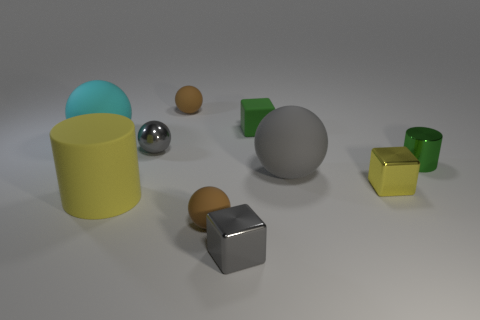Are the large gray object and the green cylinder made of the same material?
Keep it short and to the point. No. There is a green thing that is the same material as the yellow cylinder; what is its size?
Offer a very short reply. Small. What is the shape of the tiny rubber thing that is both behind the green cylinder and to the left of the tiny gray cube?
Ensure brevity in your answer.  Sphere. Is the number of green cylinders in front of the gray rubber sphere greater than the number of small gray things in front of the green metal object?
Give a very brief answer. No. What size is the rubber thing that is in front of the big cyan thing and behind the yellow cube?
Give a very brief answer. Large. What material is the thing that is the same color as the large matte cylinder?
Ensure brevity in your answer.  Metal. Is there a small matte block of the same color as the metallic ball?
Your response must be concise. No. Does the large cyan matte thing have the same shape as the large object that is to the right of the yellow cylinder?
Your answer should be very brief. Yes. Are there any other yellow cylinders made of the same material as the yellow cylinder?
Provide a succinct answer. No. There is a small brown rubber sphere that is on the left side of the tiny rubber object that is in front of the tiny green cylinder; is there a large matte cylinder right of it?
Your answer should be compact. No. 